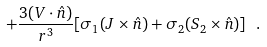Convert formula to latex. <formula><loc_0><loc_0><loc_500><loc_500>+ \frac { 3 ( { V } \cdot \hat { n } ) } { r ^ { 3 } } [ \sigma _ { 1 } ( { J } \times \hat { n } ) + \sigma _ { 2 } ( { S } _ { 2 } \times \hat { n } ) ] \ \, .</formula> 